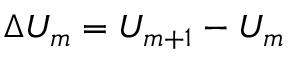<formula> <loc_0><loc_0><loc_500><loc_500>\Delta U _ { m } = U _ { m + 1 } - U _ { m }</formula> 